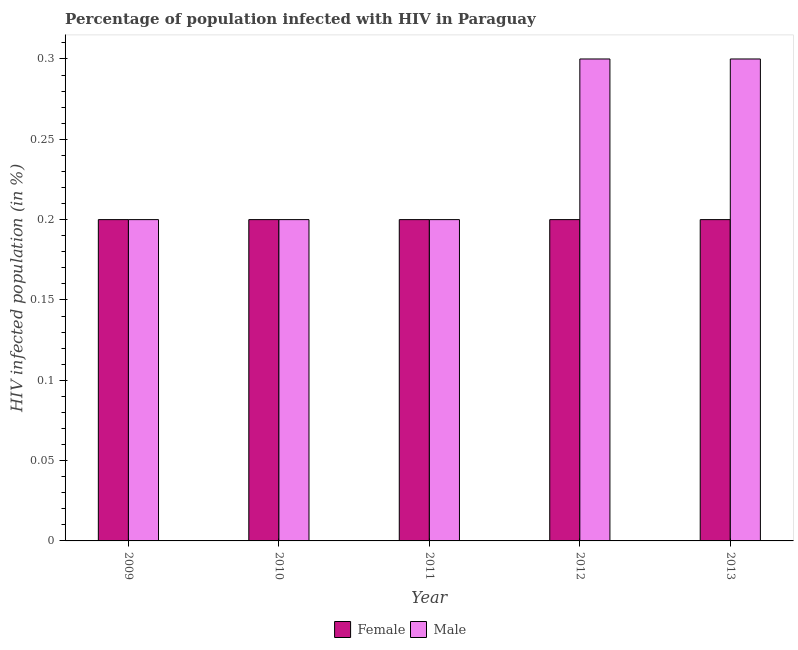How many groups of bars are there?
Keep it short and to the point. 5. Are the number of bars per tick equal to the number of legend labels?
Provide a succinct answer. Yes. Are the number of bars on each tick of the X-axis equal?
Keep it short and to the point. Yes. In how many cases, is the number of bars for a given year not equal to the number of legend labels?
Your answer should be very brief. 0. What is the total percentage of females who are infected with hiv in the graph?
Keep it short and to the point. 1. What is the difference between the percentage of females who are infected with hiv in 2010 and that in 2012?
Provide a succinct answer. 0. What is the difference between the percentage of males who are infected with hiv in 2012 and the percentage of females who are infected with hiv in 2011?
Offer a terse response. 0.1. What is the average percentage of males who are infected with hiv per year?
Your answer should be very brief. 0.24. What is the ratio of the percentage of females who are infected with hiv in 2009 to that in 2012?
Provide a succinct answer. 1. Is the percentage of males who are infected with hiv in 2010 less than that in 2011?
Keep it short and to the point. No. Is the difference between the percentage of males who are infected with hiv in 2011 and 2012 greater than the difference between the percentage of females who are infected with hiv in 2011 and 2012?
Keep it short and to the point. No. What is the difference between the highest and the second highest percentage of males who are infected with hiv?
Ensure brevity in your answer.  0. In how many years, is the percentage of males who are infected with hiv greater than the average percentage of males who are infected with hiv taken over all years?
Provide a short and direct response. 2. Is the sum of the percentage of females who are infected with hiv in 2009 and 2010 greater than the maximum percentage of males who are infected with hiv across all years?
Provide a short and direct response. Yes. What does the 2nd bar from the left in 2012 represents?
Offer a terse response. Male. What does the 1st bar from the right in 2012 represents?
Provide a short and direct response. Male. Are all the bars in the graph horizontal?
Keep it short and to the point. No. Does the graph contain grids?
Offer a terse response. No. How many legend labels are there?
Provide a short and direct response. 2. What is the title of the graph?
Offer a very short reply. Percentage of population infected with HIV in Paraguay. Does "Stunting" appear as one of the legend labels in the graph?
Make the answer very short. No. What is the label or title of the X-axis?
Provide a succinct answer. Year. What is the label or title of the Y-axis?
Offer a terse response. HIV infected population (in %). What is the HIV infected population (in %) of Male in 2009?
Keep it short and to the point. 0.2. What is the HIV infected population (in %) of Female in 2010?
Ensure brevity in your answer.  0.2. What is the HIV infected population (in %) in Female in 2011?
Give a very brief answer. 0.2. What is the HIV infected population (in %) in Male in 2011?
Provide a short and direct response. 0.2. What is the HIV infected population (in %) of Female in 2012?
Make the answer very short. 0.2. Across all years, what is the maximum HIV infected population (in %) of Female?
Ensure brevity in your answer.  0.2. Across all years, what is the maximum HIV infected population (in %) in Male?
Keep it short and to the point. 0.3. Across all years, what is the minimum HIV infected population (in %) in Female?
Your answer should be compact. 0.2. Across all years, what is the minimum HIV infected population (in %) in Male?
Your answer should be compact. 0.2. What is the total HIV infected population (in %) of Female in the graph?
Your answer should be compact. 1. What is the difference between the HIV infected population (in %) in Female in 2009 and that in 2010?
Provide a short and direct response. 0. What is the difference between the HIV infected population (in %) in Male in 2009 and that in 2010?
Your response must be concise. 0. What is the difference between the HIV infected population (in %) in Female in 2009 and that in 2011?
Your answer should be very brief. 0. What is the difference between the HIV infected population (in %) in Male in 2009 and that in 2011?
Your answer should be compact. 0. What is the difference between the HIV infected population (in %) of Male in 2009 and that in 2013?
Ensure brevity in your answer.  -0.1. What is the difference between the HIV infected population (in %) in Female in 2010 and that in 2011?
Offer a terse response. 0. What is the difference between the HIV infected population (in %) in Male in 2010 and that in 2012?
Your answer should be very brief. -0.1. What is the difference between the HIV infected population (in %) of Male in 2011 and that in 2012?
Give a very brief answer. -0.1. What is the difference between the HIV infected population (in %) of Female in 2011 and that in 2013?
Your response must be concise. 0. What is the difference between the HIV infected population (in %) in Female in 2010 and the HIV infected population (in %) in Male in 2011?
Ensure brevity in your answer.  0. What is the difference between the HIV infected population (in %) of Female in 2010 and the HIV infected population (in %) of Male in 2012?
Offer a very short reply. -0.1. What is the difference between the HIV infected population (in %) of Female in 2011 and the HIV infected population (in %) of Male in 2012?
Provide a short and direct response. -0.1. What is the difference between the HIV infected population (in %) of Female in 2011 and the HIV infected population (in %) of Male in 2013?
Your answer should be compact. -0.1. What is the difference between the HIV infected population (in %) of Female in 2012 and the HIV infected population (in %) of Male in 2013?
Keep it short and to the point. -0.1. What is the average HIV infected population (in %) of Male per year?
Your response must be concise. 0.24. In the year 2009, what is the difference between the HIV infected population (in %) of Female and HIV infected population (in %) of Male?
Keep it short and to the point. 0. In the year 2010, what is the difference between the HIV infected population (in %) of Female and HIV infected population (in %) of Male?
Offer a very short reply. 0. In the year 2013, what is the difference between the HIV infected population (in %) of Female and HIV infected population (in %) of Male?
Offer a very short reply. -0.1. What is the ratio of the HIV infected population (in %) in Male in 2009 to that in 2010?
Give a very brief answer. 1. What is the ratio of the HIV infected population (in %) of Female in 2009 to that in 2011?
Give a very brief answer. 1. What is the ratio of the HIV infected population (in %) of Male in 2009 to that in 2011?
Give a very brief answer. 1. What is the ratio of the HIV infected population (in %) of Male in 2009 to that in 2012?
Offer a very short reply. 0.67. What is the ratio of the HIV infected population (in %) in Male in 2009 to that in 2013?
Your response must be concise. 0.67. What is the ratio of the HIV infected population (in %) of Female in 2010 to that in 2011?
Give a very brief answer. 1. What is the ratio of the HIV infected population (in %) of Male in 2010 to that in 2011?
Offer a very short reply. 1. What is the ratio of the HIV infected population (in %) of Female in 2010 to that in 2012?
Provide a succinct answer. 1. What is the ratio of the HIV infected population (in %) of Male in 2011 to that in 2012?
Your answer should be very brief. 0.67. What is the ratio of the HIV infected population (in %) in Male in 2011 to that in 2013?
Give a very brief answer. 0.67. What is the ratio of the HIV infected population (in %) in Female in 2012 to that in 2013?
Keep it short and to the point. 1. What is the ratio of the HIV infected population (in %) in Male in 2012 to that in 2013?
Make the answer very short. 1. What is the difference between the highest and the second highest HIV infected population (in %) in Female?
Ensure brevity in your answer.  0. What is the difference between the highest and the second highest HIV infected population (in %) of Male?
Ensure brevity in your answer.  0. 